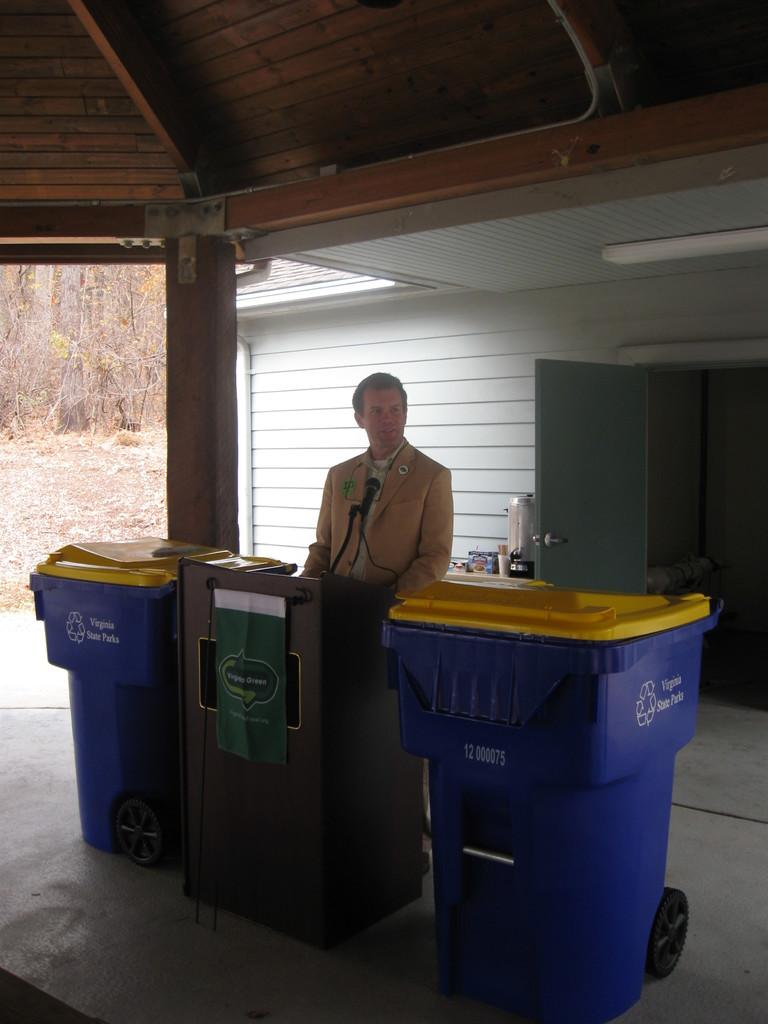<image>
Provide a brief description of the given image. A man stands at a podium between two garbage cans that say Virginia State Parks. 